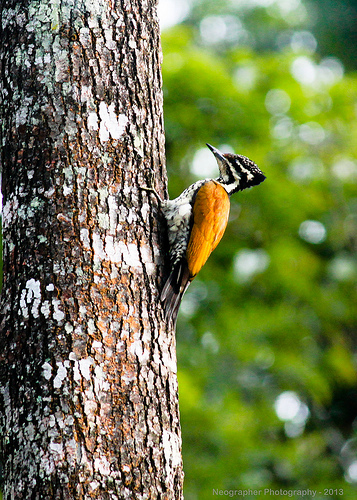Please provide the bounding box coordinate of the region this sentence describes: the tail feathers of a bird. The coordinates [0.46, 0.5, 0.54, 0.62] focus on the tail feathers of the bird, highlighting the spread that helps in flight stabilization and showcasing varied coloration. 